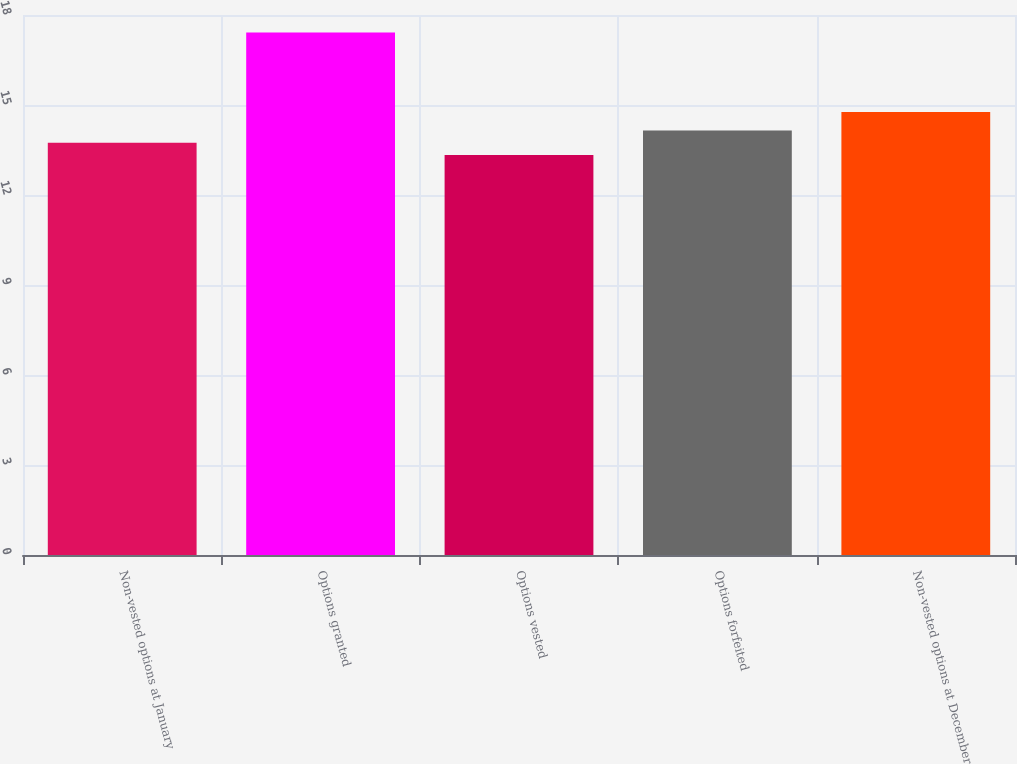<chart> <loc_0><loc_0><loc_500><loc_500><bar_chart><fcel>Non-vested options at January<fcel>Options granted<fcel>Options vested<fcel>Options forfeited<fcel>Non-vested options at December<nl><fcel>13.74<fcel>17.42<fcel>13.33<fcel>14.15<fcel>14.77<nl></chart> 